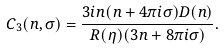<formula> <loc_0><loc_0><loc_500><loc_500>C _ { 3 } ( n , \sigma ) = \frac { 3 i n ( n + 4 \pi i \sigma ) D ( n ) } { R ( \eta ) ( 3 n + 8 \pi i \sigma ) } .</formula> 